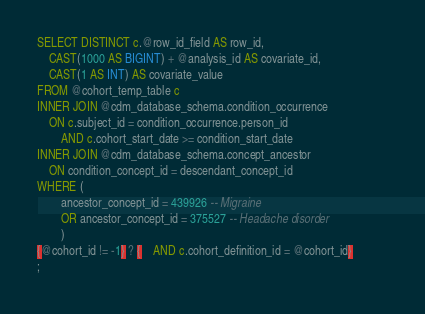<code> <loc_0><loc_0><loc_500><loc_500><_SQL_>SELECT DISTINCT c.@row_id_field AS row_id,
	CAST(1000 AS BIGINT) + @analysis_id AS covariate_id,
	CAST(1 AS INT) AS covariate_value
FROM @cohort_temp_table c
INNER JOIN @cdm_database_schema.condition_occurrence
	ON c.subject_id = condition_occurrence.person_id
		AND c.cohort_start_date >= condition_start_date
INNER JOIN @cdm_database_schema.concept_ancestor
	ON condition_concept_id = descendant_concept_id
WHERE (
		ancestor_concept_id = 439926 -- Migraine
		OR ancestor_concept_id = 375527 -- Headache disorder
		)
{@cohort_id != -1} ? {	AND c.cohort_definition_id = @cohort_id}			
;
</code> 